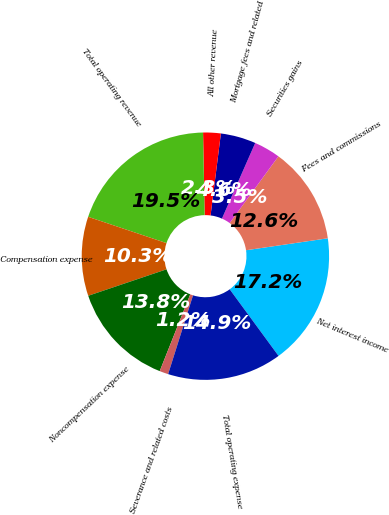Convert chart to OTSL. <chart><loc_0><loc_0><loc_500><loc_500><pie_chart><fcel>Net interest income<fcel>Fees and commissions<fcel>Securities gains<fcel>Mortgage fees and related<fcel>All other revenue<fcel>Total operating revenue<fcel>Compensation expense<fcel>Noncompensation expense<fcel>Severance and related costs<fcel>Total operating expense<nl><fcel>17.24%<fcel>12.64%<fcel>3.45%<fcel>4.6%<fcel>2.3%<fcel>19.54%<fcel>10.34%<fcel>13.79%<fcel>1.15%<fcel>14.94%<nl></chart> 